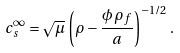<formula> <loc_0><loc_0><loc_500><loc_500>c _ { s } ^ { \infty } = \sqrt { \mu } \, \left ( \rho - \frac { \phi \, \rho _ { f } } { a } \right ) ^ { - 1 / 2 } .</formula> 